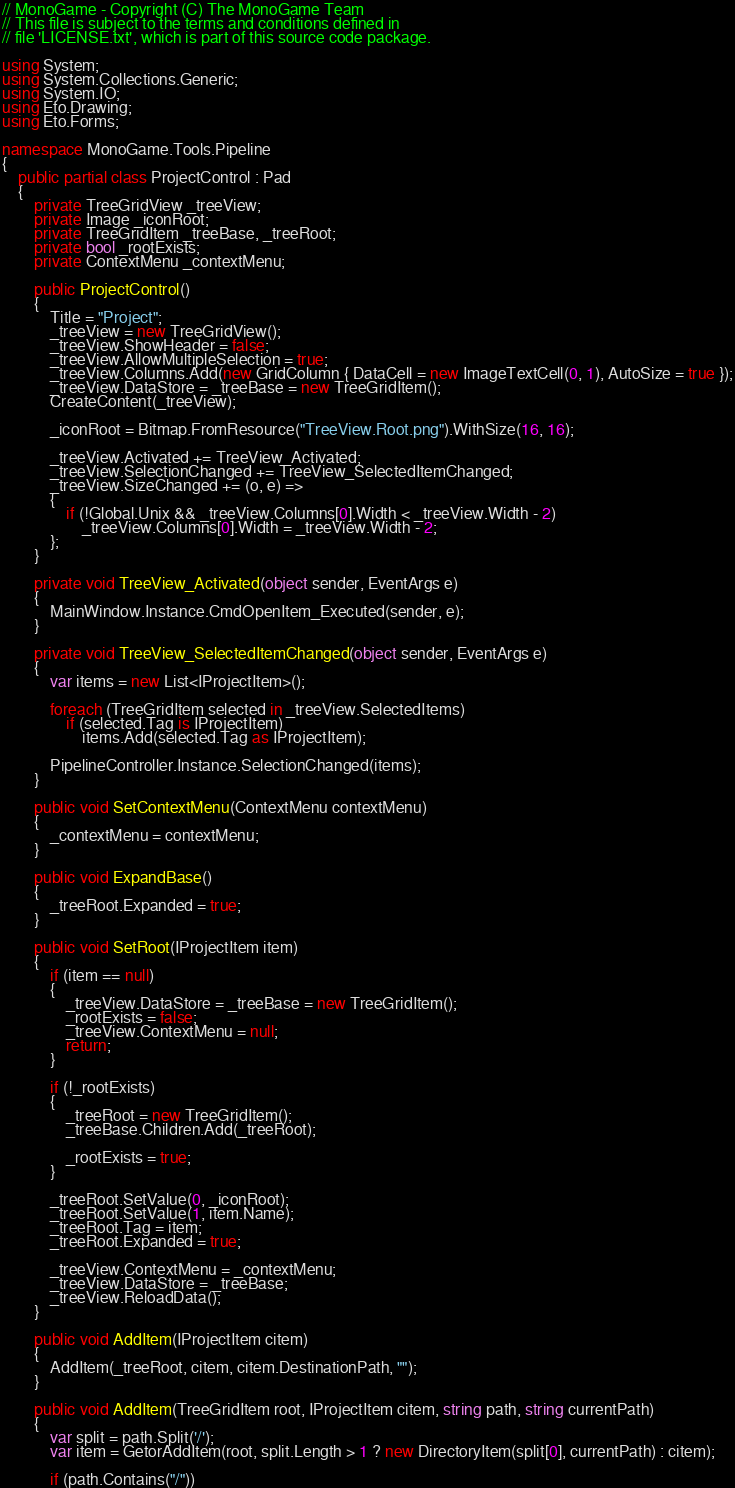<code> <loc_0><loc_0><loc_500><loc_500><_C#_>// MonoGame - Copyright (C) The MonoGame Team
// This file is subject to the terms and conditions defined in
// file 'LICENSE.txt', which is part of this source code package.

using System;
using System.Collections.Generic;
using System.IO;
using Eto.Drawing;
using Eto.Forms;

namespace MonoGame.Tools.Pipeline
{
    public partial class ProjectControl : Pad
    {
        private TreeGridView _treeView;
        private Image _iconRoot;
        private TreeGridItem _treeBase, _treeRoot;
        private bool _rootExists;
        private ContextMenu _contextMenu;

        public ProjectControl()
        {
            Title = "Project";
            _treeView = new TreeGridView();
            _treeView.ShowHeader = false;
            _treeView.AllowMultipleSelection = true;
            _treeView.Columns.Add(new GridColumn { DataCell = new ImageTextCell(0, 1), AutoSize = true });
            _treeView.DataStore = _treeBase = new TreeGridItem();
            CreateContent(_treeView);

            _iconRoot = Bitmap.FromResource("TreeView.Root.png").WithSize(16, 16);

            _treeView.Activated += TreeView_Activated;
            _treeView.SelectionChanged += TreeView_SelectedItemChanged;
            _treeView.SizeChanged += (o, e) =>
            {
                if (!Global.Unix && _treeView.Columns[0].Width < _treeView.Width - 2)
                    _treeView.Columns[0].Width = _treeView.Width - 2;
            };
        }

        private void TreeView_Activated(object sender, EventArgs e)
        {
            MainWindow.Instance.CmdOpenItem_Executed(sender, e);
        }

        private void TreeView_SelectedItemChanged(object sender, EventArgs e)
        {
            var items = new List<IProjectItem>();

            foreach (TreeGridItem selected in _treeView.SelectedItems)
                if (selected.Tag is IProjectItem)
                    items.Add(selected.Tag as IProjectItem);

            PipelineController.Instance.SelectionChanged(items);
        }

        public void SetContextMenu(ContextMenu contextMenu)
        {
            _contextMenu = contextMenu;
        }

        public void ExpandBase()
        {
            _treeRoot.Expanded = true;
        }

        public void SetRoot(IProjectItem item)
        {
            if (item == null)
            {
                _treeView.DataStore = _treeBase = new TreeGridItem();
                _rootExists = false;
                _treeView.ContextMenu = null;
                return;
            }

            if (!_rootExists)
            {
                _treeRoot = new TreeGridItem();
                _treeBase.Children.Add(_treeRoot);

                _rootExists = true;
            }

            _treeRoot.SetValue(0, _iconRoot);
            _treeRoot.SetValue(1, item.Name);
            _treeRoot.Tag = item;
            _treeRoot.Expanded = true;

            _treeView.ContextMenu = _contextMenu;
            _treeView.DataStore = _treeBase;
            _treeView.ReloadData();
        }

        public void AddItem(IProjectItem citem)
        {
            AddItem(_treeRoot, citem, citem.DestinationPath, "");
        }

        public void AddItem(TreeGridItem root, IProjectItem citem, string path, string currentPath)
        {
            var split = path.Split('/');
            var item = GetorAddItem(root, split.Length > 1 ? new DirectoryItem(split[0], currentPath) : citem);

            if (path.Contains("/"))</code> 